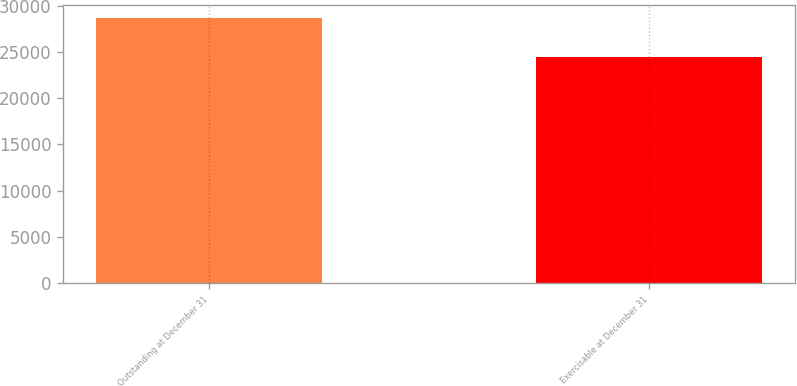<chart> <loc_0><loc_0><loc_500><loc_500><bar_chart><fcel>Outstanding at December 31<fcel>Exercisable at December 31<nl><fcel>28654<fcel>24412<nl></chart> 